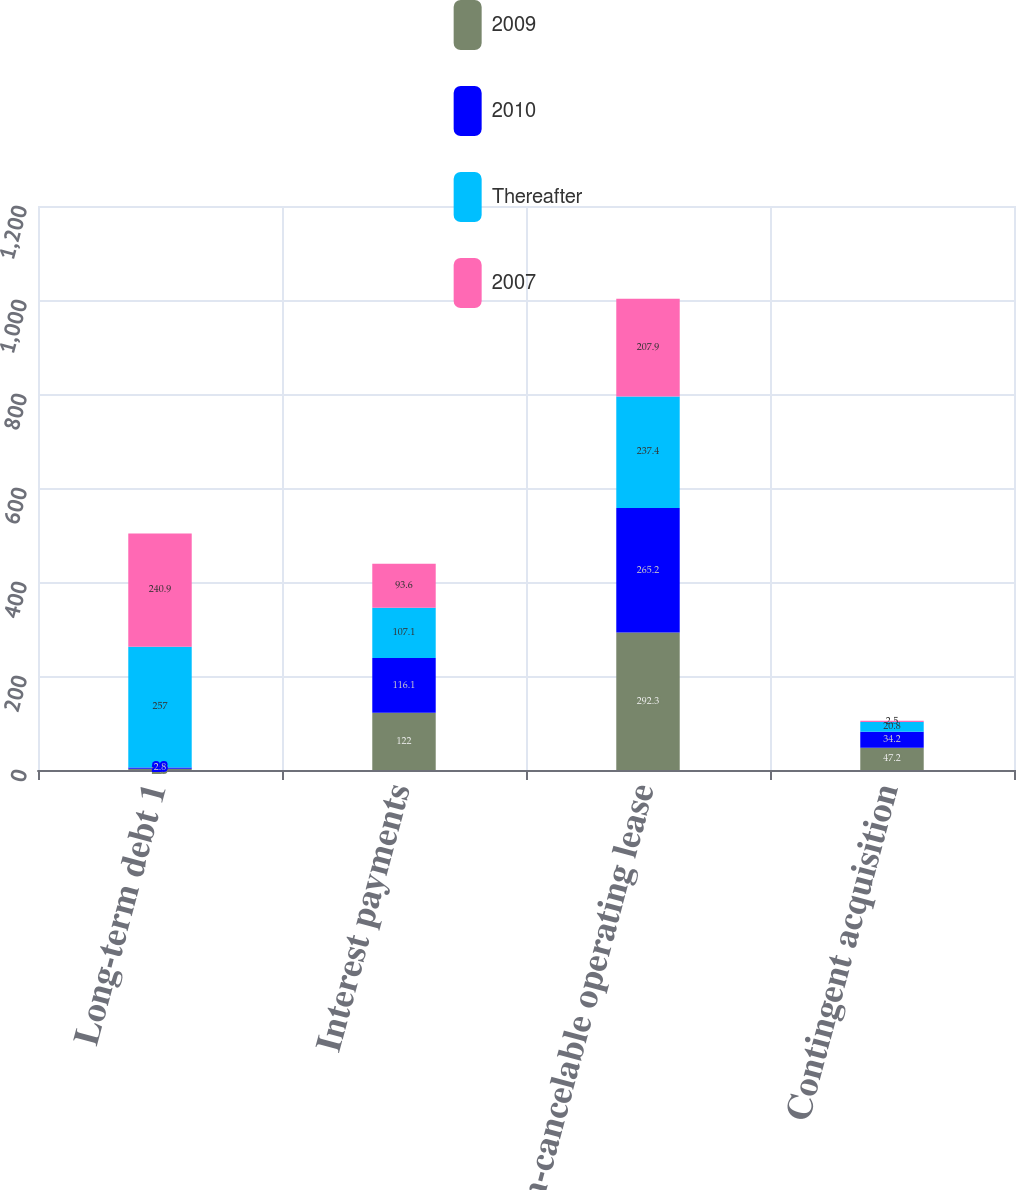Convert chart. <chart><loc_0><loc_0><loc_500><loc_500><stacked_bar_chart><ecel><fcel>Long-term debt 1<fcel>Interest payments<fcel>Non-cancelable operating lease<fcel>Contingent acquisition<nl><fcel>2009<fcel>2.6<fcel>122<fcel>292.3<fcel>47.2<nl><fcel>2010<fcel>2.8<fcel>116.1<fcel>265.2<fcel>34.2<nl><fcel>Thereafter<fcel>257<fcel>107.1<fcel>237.4<fcel>20.8<nl><fcel>2007<fcel>240.9<fcel>93.6<fcel>207.9<fcel>2.5<nl></chart> 